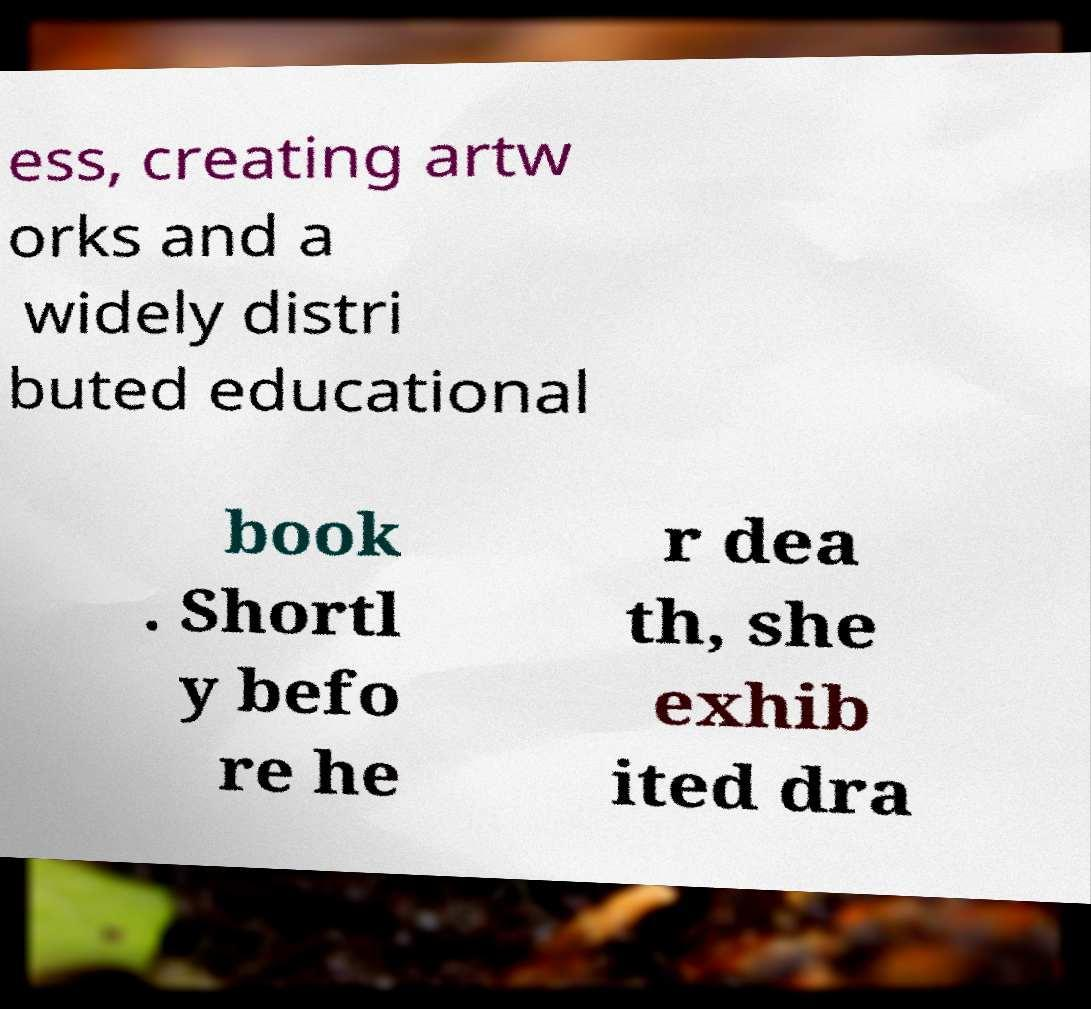Please read and relay the text visible in this image. What does it say? ess, creating artw orks and a widely distri buted educational book . Shortl y befo re he r dea th, she exhib ited dra 